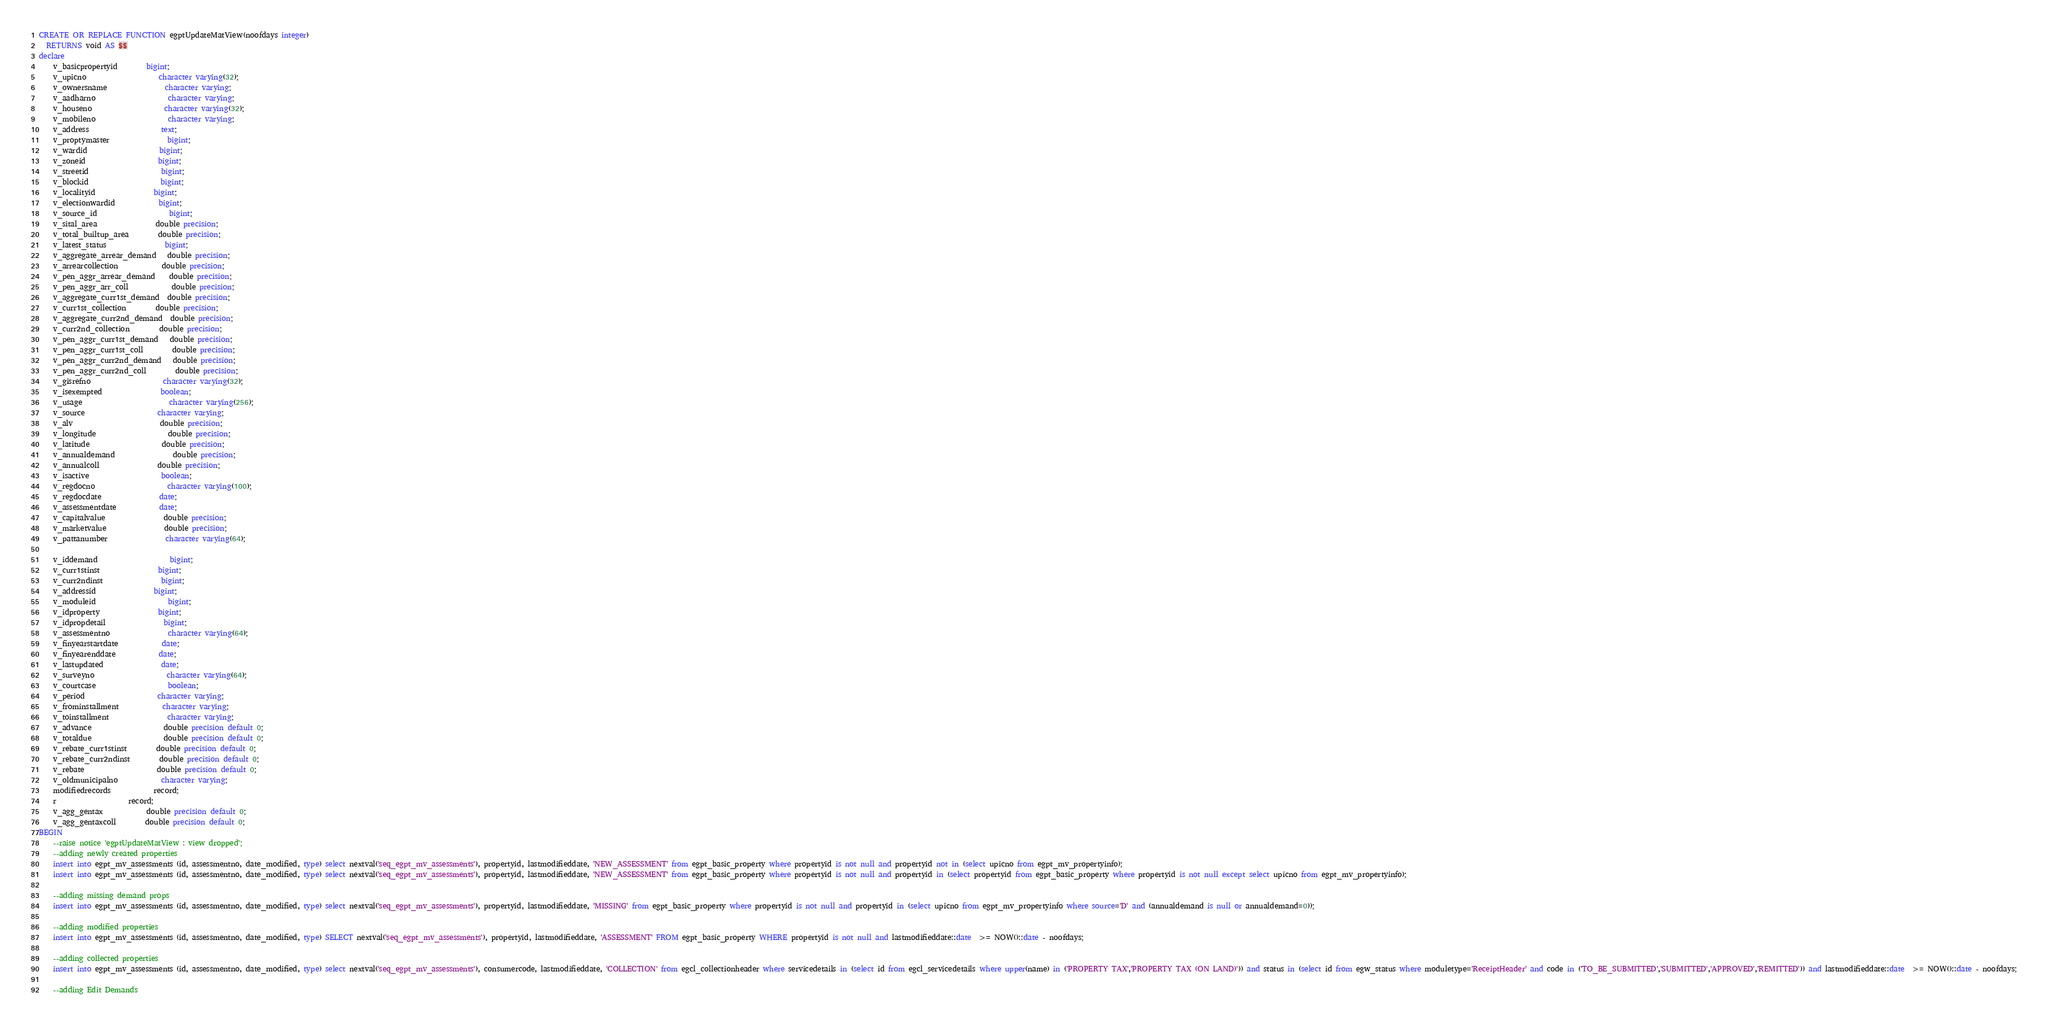Convert code to text. <code><loc_0><loc_0><loc_500><loc_500><_SQL_>CREATE OR REPLACE FUNCTION egptUpdateMatView(noofdays integer)
  RETURNS void AS $$
declare
	v_basicpropertyid   		bigint;
	v_upicno    				character varying(32);
	v_ownersname    			character varying;
	v_aadharno    				character varying;
	v_houseno    				character varying(32);
	v_mobileno    				character varying;
	v_address    				text;
	v_proptymaster    			bigint;
	v_wardid    				bigint;
	v_zoneid    				bigint;
	v_streetid    				bigint;
	v_blockid    				bigint;
	v_localityid    			bigint;
	v_electionwardid    		bigint;
	v_source_id    				bigint;
	v_sital_area    			double precision;
	v_total_builtup_area    	double precision;
	v_latest_status    			bigint;
	v_aggregate_arrear_demand   double precision;
	v_arrearcollection    		double precision;
	v_pen_aggr_arrear_demand    double precision;
	v_pen_aggr_arr_coll    		double precision;
	v_aggregate_curr1st_demand  double precision;
	v_curr1st_collection    	double precision;
	v_aggregate_curr2nd_demand  double precision;
	v_curr2nd_collection    	double precision;
	v_pen_aggr_curr1st_demand   double precision;
	v_pen_aggr_curr1st_coll    	double precision;
	v_pen_aggr_curr2nd_demand   double precision;
	v_pen_aggr_curr2nd_coll    	double precision;
	v_gisrefno    				character varying(32);
	v_isexempted    			boolean;
	v_usage    					character varying(256);
	v_source    				character varying;
	v_alv    					double precision;	
	v_longitude    				double precision;
	v_latitude    				double precision;
	v_annualdemand    			double precision;
	v_annualcoll    			double precision;
	v_isactive    				boolean;
	v_regdocno					character varying(100);
	v_regdocdate				date;
	v_assessmentdate			date;
	v_capitalvalue				double precision;
	v_marketvalue				double precision;
	v_pattanumber				character varying(64);
	
	v_iddemand 					bigint;
	v_curr1stinst 				bigint;
	v_curr2ndinst 				bigint;
	v_addressid 				bigint;
	v_moduleid 					bigint;
	v_idproperty 				bigint;
	v_idpropdetail 				bigint;
	v_assessmentno 				character varying(64);
	v_finyearstartdate 			date;
	v_finyearenddate 			date;
	v_lastupdated				date;
	v_surveyno					character varying(64);
	v_courtcase    				boolean;
	v_period    				character varying;
	v_frominstallment			character varying;
	v_toinstallment				character varying;
	v_advance    				double precision default 0;
	v_totaldue    				double precision default 0;
	v_rebate_curr1stinst		double precision default 0;
	v_rebate_curr2ndinst    	double precision default 0;
	v_rebate    				double precision default 0;
	v_oldmunicipalno			character varying;
	modifiedrecords 			record;
	r 					record;
	v_agg_gentax 			double precision default 0;
	v_agg_gentaxcoll 	 	double precision default 0;
BEGIN
	--raise notice 'egptUpdateMatView : view dropped';
	--adding newly created properties
	insert into egpt_mv_assessments (id, assessmentno, date_modified, type) select nextval('seq_egpt_mv_assessments'), propertyid, lastmodifieddate, 'NEW_ASSESSMENT' from egpt_basic_property where propertyid is not null and propertyid not in (select upicno from egpt_mv_propertyinfo);
	insert into egpt_mv_assessments (id, assessmentno, date_modified, type) select nextval('seq_egpt_mv_assessments'), propertyid, lastmodifieddate, 'NEW_ASSESSMENT' from egpt_basic_property where propertyid is not null and propertyid in (select propertyid from egpt_basic_property where propertyid is not null except select upicno from egpt_mv_propertyinfo);

	--adding missing demand props
	insert into egpt_mv_assessments (id, assessmentno, date_modified, type) select nextval('seq_egpt_mv_assessments'), propertyid, lastmodifieddate, 'MISSING' from egpt_basic_property where propertyid is not null and propertyid in (select upicno from egpt_mv_propertyinfo where source='D' and (annualdemand is null or annualdemand=0));

	--adding modified properties
	insert into egpt_mv_assessments (id, assessmentno, date_modified, type) SELECT nextval('seq_egpt_mv_assessments'), propertyid, lastmodifieddate, 'ASSESSMENT' FROM egpt_basic_property WHERE propertyid is not null and lastmodifieddate::date  >= NOW()::date - noofdays;

	--adding collected properties
	insert into egpt_mv_assessments (id, assessmentno, date_modified, type) select nextval('seq_egpt_mv_assessments'), consumercode, lastmodifieddate, 'COLLECTION' from egcl_collectionheader where servicedetails in (select id from egcl_servicedetails where upper(name) in ('PROPERTY TAX','PROPERTY TAX (ON LAND)')) and status in (select id from egw_status where moduletype='ReceiptHeader' and code in ('TO_BE_SUBMITTED','SUBMITTED','APPROVED','REMITTED')) and lastmodifieddate::date  >= NOW()::date - noofdays;

	--adding Edit Demands</code> 